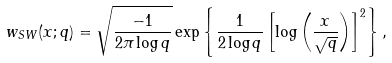<formula> <loc_0><loc_0><loc_500><loc_500>w _ { S W } ( x ; q ) = \sqrt { \frac { - 1 } { 2 \pi \log q } } \exp \left \{ \frac { 1 } { 2 \log q } \left [ \log \left ( \frac { x } { \sqrt { q } } \right ) \right ] ^ { 2 } \right \} ,</formula> 